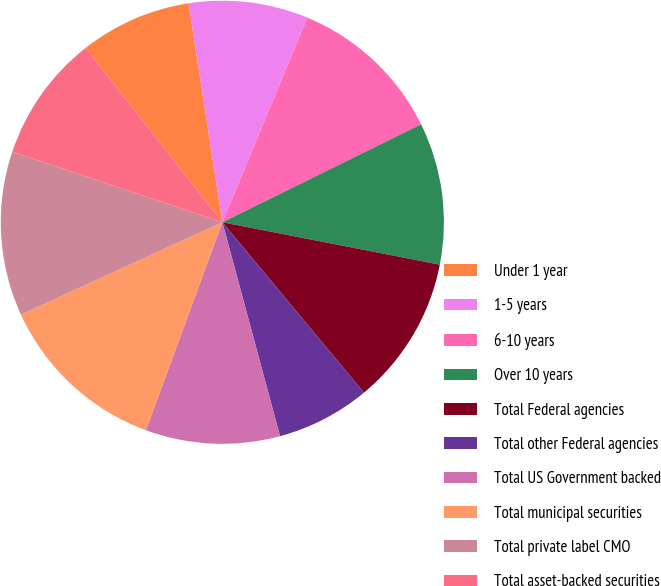Convert chart. <chart><loc_0><loc_0><loc_500><loc_500><pie_chart><fcel>Under 1 year<fcel>1-5 years<fcel>6-10 years<fcel>Over 10 years<fcel>Total Federal agencies<fcel>Total other Federal agencies<fcel>Total US Government backed<fcel>Total municipal securities<fcel>Total private label CMO<fcel>Total asset-backed securities<nl><fcel>8.15%<fcel>8.7%<fcel>11.45%<fcel>10.35%<fcel>10.9%<fcel>6.84%<fcel>9.8%<fcel>12.55%<fcel>12.0%<fcel>9.25%<nl></chart> 